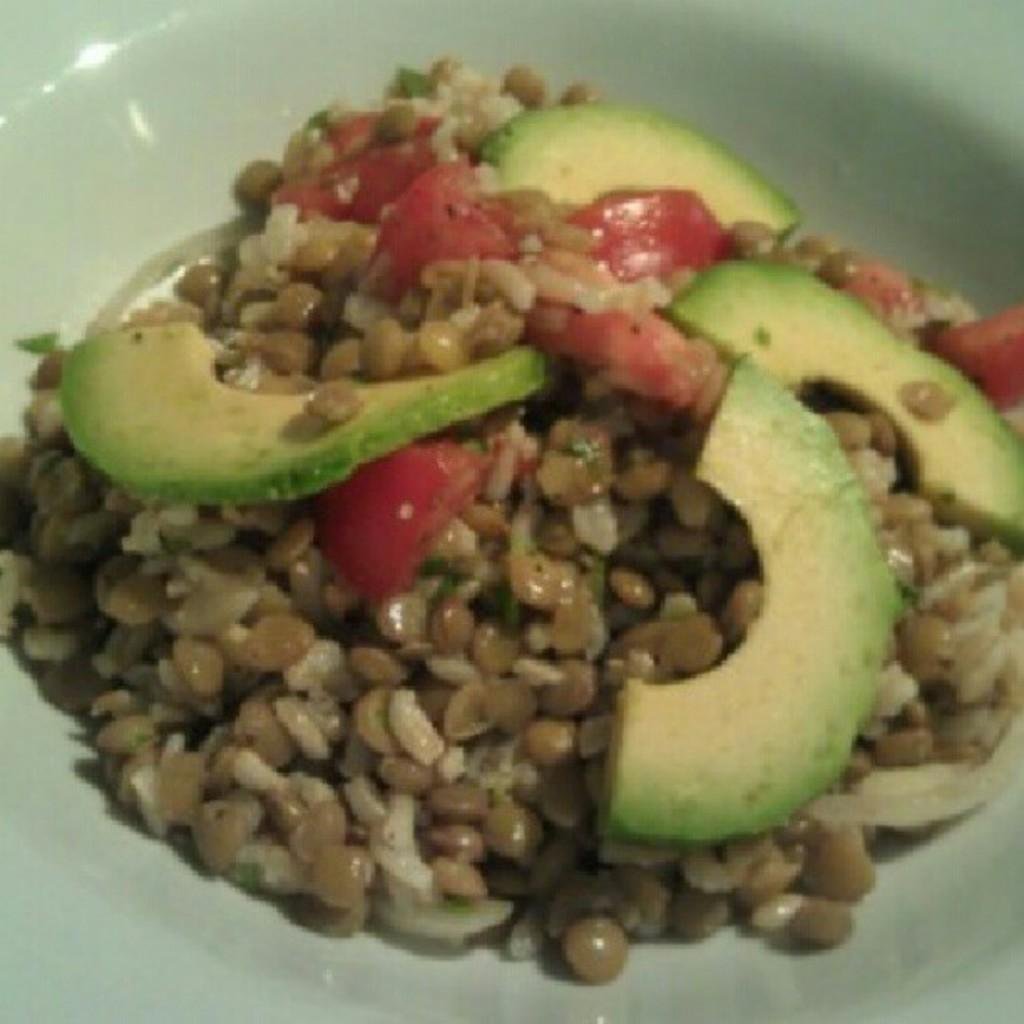What is present on the plate in the image? There is a plate of food items in the image. What type of print can be seen on the plate in the image? There is no print visible on the plate in the image. Are there any mice present in the image? There are no mice present in the image. 